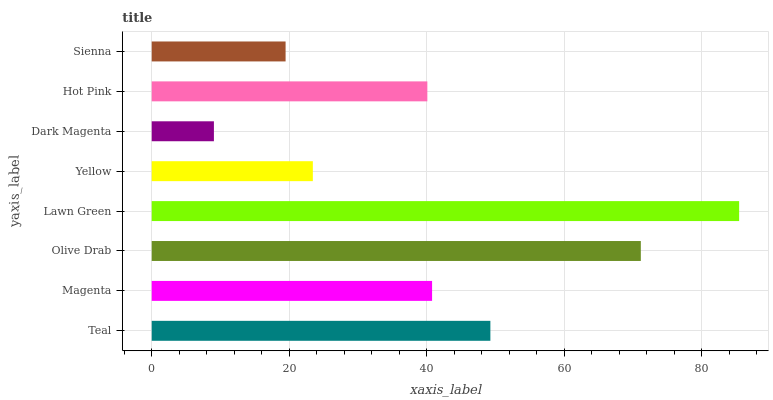Is Dark Magenta the minimum?
Answer yes or no. Yes. Is Lawn Green the maximum?
Answer yes or no. Yes. Is Magenta the minimum?
Answer yes or no. No. Is Magenta the maximum?
Answer yes or no. No. Is Teal greater than Magenta?
Answer yes or no. Yes. Is Magenta less than Teal?
Answer yes or no. Yes. Is Magenta greater than Teal?
Answer yes or no. No. Is Teal less than Magenta?
Answer yes or no. No. Is Magenta the high median?
Answer yes or no. Yes. Is Hot Pink the low median?
Answer yes or no. Yes. Is Teal the high median?
Answer yes or no. No. Is Yellow the low median?
Answer yes or no. No. 